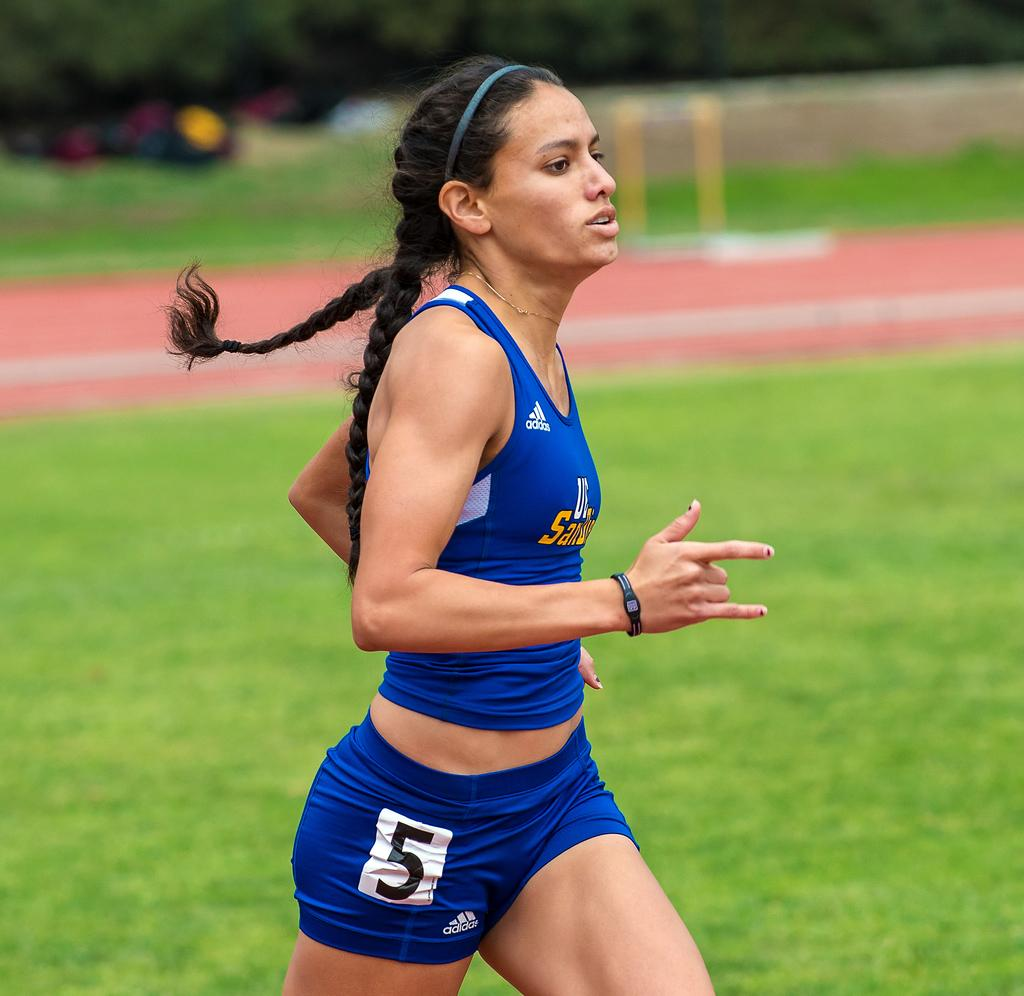<image>
Summarize the visual content of the image. A femal runner dressed in blue top and shorts carrying the number 5 is seen running by close up. 